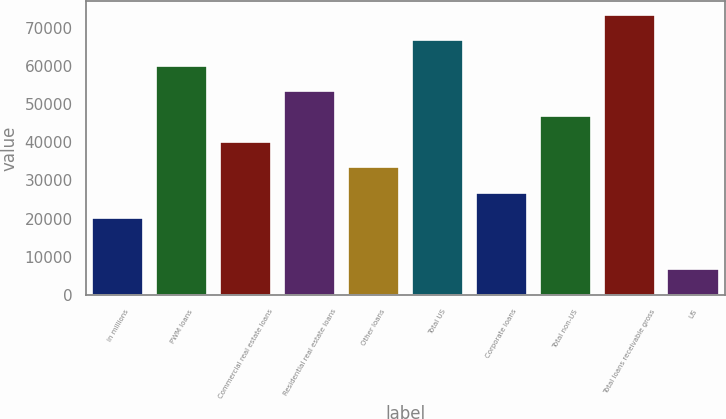Convert chart. <chart><loc_0><loc_0><loc_500><loc_500><bar_chart><fcel>in millions<fcel>PWM loans<fcel>Commercial real estate loans<fcel>Residential real estate loans<fcel>Other loans<fcel>Total US<fcel>Corporate loans<fcel>Total non-US<fcel>Total loans receivable gross<fcel>US<nl><fcel>20160.1<fcel>60082.3<fcel>40121.2<fcel>53428.6<fcel>33467.5<fcel>66736<fcel>26813.8<fcel>46774.9<fcel>73389.7<fcel>6852.7<nl></chart> 